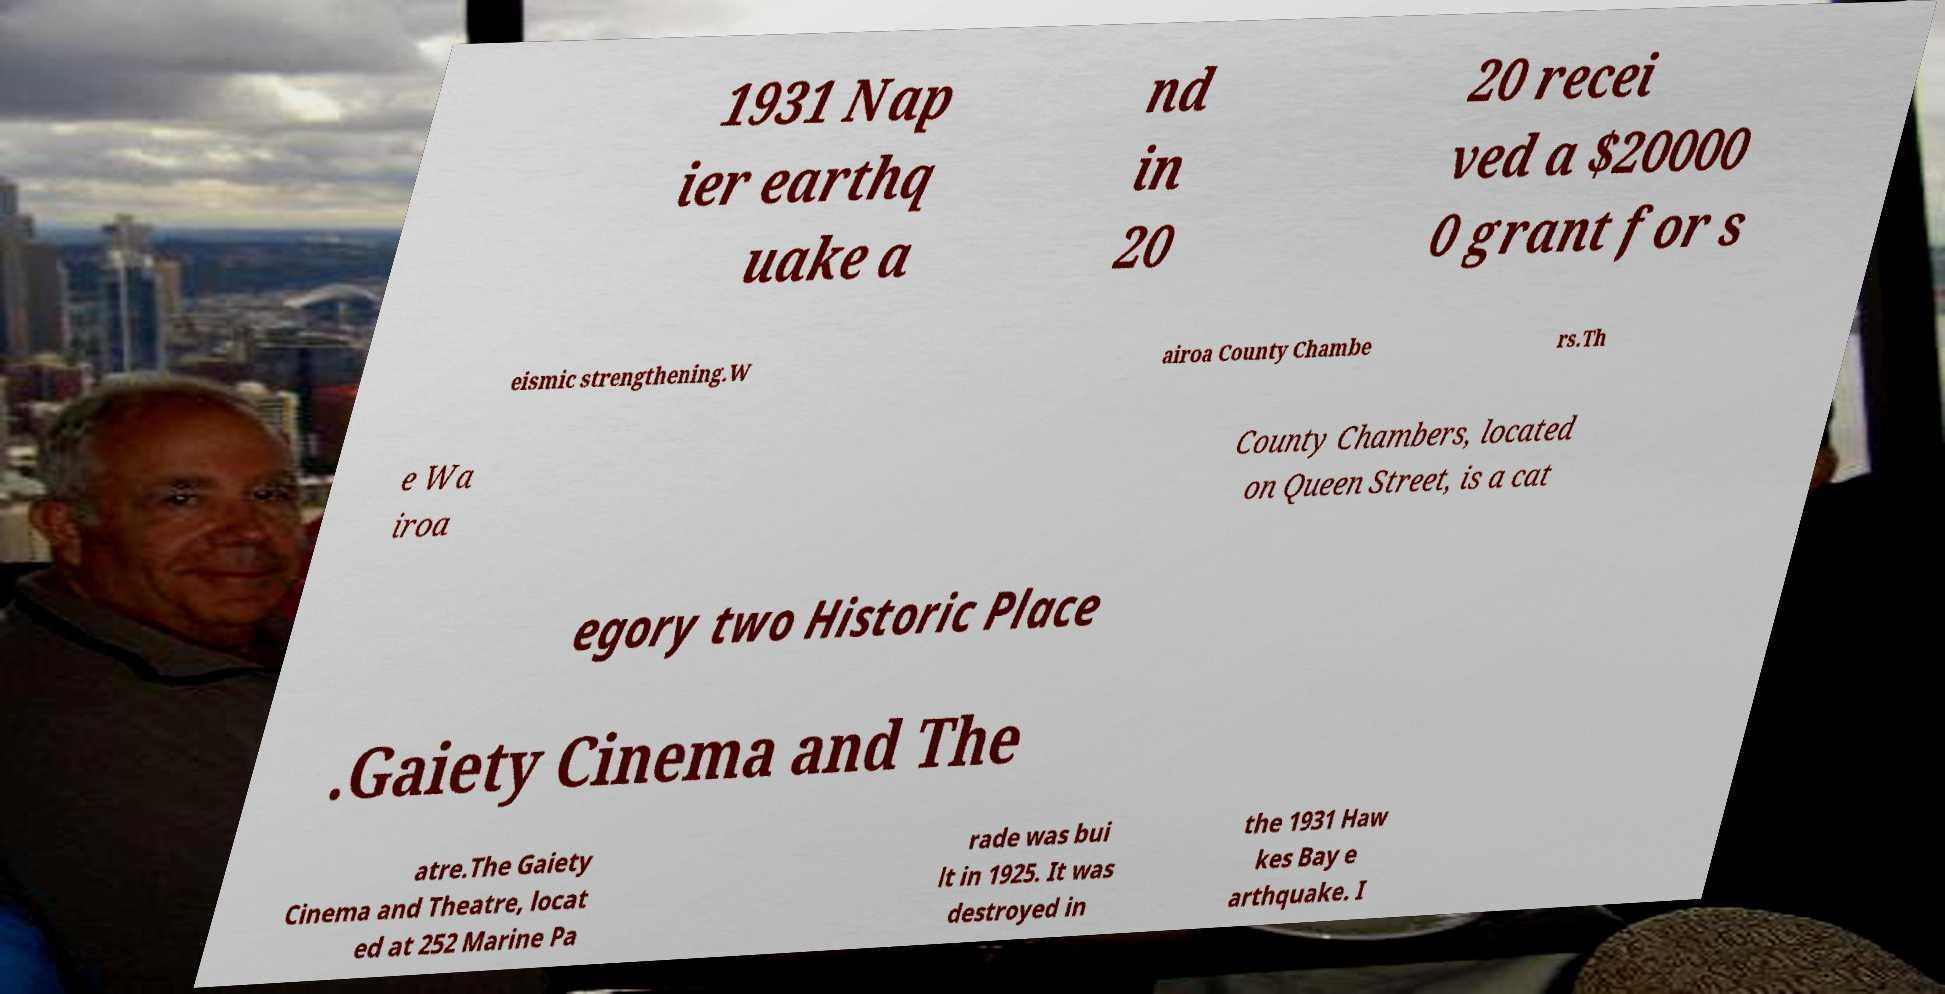What messages or text are displayed in this image? I need them in a readable, typed format. 1931 Nap ier earthq uake a nd in 20 20 recei ved a $20000 0 grant for s eismic strengthening.W airoa County Chambe rs.Th e Wa iroa County Chambers, located on Queen Street, is a cat egory two Historic Place .Gaiety Cinema and The atre.The Gaiety Cinema and Theatre, locat ed at 252 Marine Pa rade was bui lt in 1925. It was destroyed in the 1931 Haw kes Bay e arthquake. I 